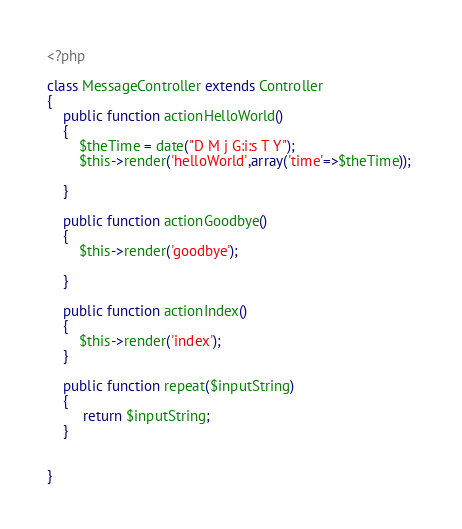<code> <loc_0><loc_0><loc_500><loc_500><_PHP_><?php

class MessageController extends Controller
{
	public function actionHelloWorld()
	{
		$theTime = date("D M j G:i:s T Y");
		$this->render('helloWorld',array('time'=>$theTime)); 
		
	}
	
	public function actionGoodbye()
	{
		$this->render('goodbye'); 
		
	}

	public function actionIndex()
	{
		$this->render('index');
	}
	
	public function repeat($inputString)
	{
	     return $inputString;
	} 
	

}</code> 